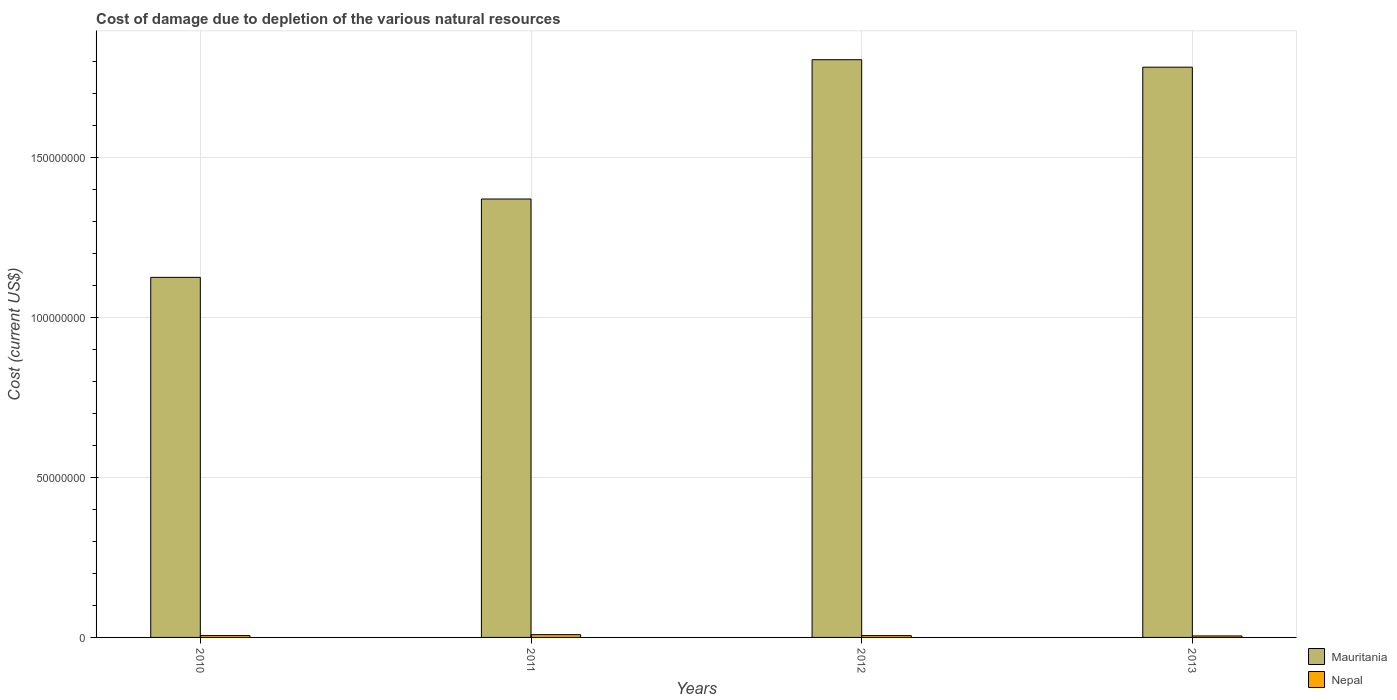Are the number of bars on each tick of the X-axis equal?
Keep it short and to the point. Yes. How many bars are there on the 2nd tick from the right?
Your response must be concise. 2. In how many cases, is the number of bars for a given year not equal to the number of legend labels?
Give a very brief answer. 0. What is the cost of damage caused due to the depletion of various natural resources in Nepal in 2011?
Your answer should be very brief. 8.69e+05. Across all years, what is the maximum cost of damage caused due to the depletion of various natural resources in Mauritania?
Make the answer very short. 1.81e+08. Across all years, what is the minimum cost of damage caused due to the depletion of various natural resources in Nepal?
Make the answer very short. 4.64e+05. What is the total cost of damage caused due to the depletion of various natural resources in Mauritania in the graph?
Offer a terse response. 6.09e+08. What is the difference between the cost of damage caused due to the depletion of various natural resources in Nepal in 2011 and that in 2012?
Keep it short and to the point. 2.92e+05. What is the difference between the cost of damage caused due to the depletion of various natural resources in Nepal in 2011 and the cost of damage caused due to the depletion of various natural resources in Mauritania in 2013?
Give a very brief answer. -1.77e+08. What is the average cost of damage caused due to the depletion of various natural resources in Mauritania per year?
Make the answer very short. 1.52e+08. In the year 2010, what is the difference between the cost of damage caused due to the depletion of various natural resources in Mauritania and cost of damage caused due to the depletion of various natural resources in Nepal?
Provide a short and direct response. 1.12e+08. In how many years, is the cost of damage caused due to the depletion of various natural resources in Mauritania greater than 150000000 US$?
Ensure brevity in your answer.  2. What is the ratio of the cost of damage caused due to the depletion of various natural resources in Nepal in 2010 to that in 2012?
Your response must be concise. 1.01. Is the cost of damage caused due to the depletion of various natural resources in Mauritania in 2011 less than that in 2013?
Your answer should be compact. Yes. What is the difference between the highest and the second highest cost of damage caused due to the depletion of various natural resources in Mauritania?
Provide a short and direct response. 2.34e+06. What is the difference between the highest and the lowest cost of damage caused due to the depletion of various natural resources in Nepal?
Your answer should be very brief. 4.05e+05. In how many years, is the cost of damage caused due to the depletion of various natural resources in Nepal greater than the average cost of damage caused due to the depletion of various natural resources in Nepal taken over all years?
Provide a short and direct response. 1. Is the sum of the cost of damage caused due to the depletion of various natural resources in Mauritania in 2011 and 2012 greater than the maximum cost of damage caused due to the depletion of various natural resources in Nepal across all years?
Offer a very short reply. Yes. What does the 1st bar from the left in 2012 represents?
Your answer should be very brief. Mauritania. What does the 2nd bar from the right in 2012 represents?
Your answer should be compact. Mauritania. How many bars are there?
Your answer should be compact. 8. Are all the bars in the graph horizontal?
Offer a terse response. No. How many years are there in the graph?
Give a very brief answer. 4. Are the values on the major ticks of Y-axis written in scientific E-notation?
Offer a very short reply. No. Does the graph contain any zero values?
Offer a terse response. No. Does the graph contain grids?
Keep it short and to the point. Yes. Where does the legend appear in the graph?
Ensure brevity in your answer.  Bottom right. How many legend labels are there?
Offer a very short reply. 2. What is the title of the graph?
Provide a short and direct response. Cost of damage due to depletion of the various natural resources. Does "Lebanon" appear as one of the legend labels in the graph?
Keep it short and to the point. No. What is the label or title of the Y-axis?
Make the answer very short. Cost (current US$). What is the Cost (current US$) in Mauritania in 2010?
Your response must be concise. 1.13e+08. What is the Cost (current US$) of Nepal in 2010?
Keep it short and to the point. 5.84e+05. What is the Cost (current US$) in Mauritania in 2011?
Your answer should be compact. 1.37e+08. What is the Cost (current US$) in Nepal in 2011?
Make the answer very short. 8.69e+05. What is the Cost (current US$) of Mauritania in 2012?
Give a very brief answer. 1.81e+08. What is the Cost (current US$) of Nepal in 2012?
Provide a succinct answer. 5.78e+05. What is the Cost (current US$) in Mauritania in 2013?
Keep it short and to the point. 1.78e+08. What is the Cost (current US$) of Nepal in 2013?
Your answer should be very brief. 4.64e+05. Across all years, what is the maximum Cost (current US$) in Mauritania?
Your answer should be very brief. 1.81e+08. Across all years, what is the maximum Cost (current US$) of Nepal?
Your response must be concise. 8.69e+05. Across all years, what is the minimum Cost (current US$) in Mauritania?
Offer a very short reply. 1.13e+08. Across all years, what is the minimum Cost (current US$) in Nepal?
Your answer should be very brief. 4.64e+05. What is the total Cost (current US$) in Mauritania in the graph?
Offer a very short reply. 6.09e+08. What is the total Cost (current US$) in Nepal in the graph?
Your answer should be very brief. 2.49e+06. What is the difference between the Cost (current US$) in Mauritania in 2010 and that in 2011?
Provide a succinct answer. -2.45e+07. What is the difference between the Cost (current US$) of Nepal in 2010 and that in 2011?
Your answer should be very brief. -2.85e+05. What is the difference between the Cost (current US$) of Mauritania in 2010 and that in 2012?
Give a very brief answer. -6.81e+07. What is the difference between the Cost (current US$) of Nepal in 2010 and that in 2012?
Offer a very short reply. 6660.31. What is the difference between the Cost (current US$) of Mauritania in 2010 and that in 2013?
Your answer should be very brief. -6.57e+07. What is the difference between the Cost (current US$) in Nepal in 2010 and that in 2013?
Make the answer very short. 1.20e+05. What is the difference between the Cost (current US$) of Mauritania in 2011 and that in 2012?
Make the answer very short. -4.36e+07. What is the difference between the Cost (current US$) of Nepal in 2011 and that in 2012?
Your response must be concise. 2.92e+05. What is the difference between the Cost (current US$) of Mauritania in 2011 and that in 2013?
Give a very brief answer. -4.12e+07. What is the difference between the Cost (current US$) of Nepal in 2011 and that in 2013?
Provide a short and direct response. 4.05e+05. What is the difference between the Cost (current US$) in Mauritania in 2012 and that in 2013?
Your response must be concise. 2.34e+06. What is the difference between the Cost (current US$) in Nepal in 2012 and that in 2013?
Give a very brief answer. 1.14e+05. What is the difference between the Cost (current US$) of Mauritania in 2010 and the Cost (current US$) of Nepal in 2011?
Your answer should be very brief. 1.12e+08. What is the difference between the Cost (current US$) of Mauritania in 2010 and the Cost (current US$) of Nepal in 2012?
Offer a very short reply. 1.12e+08. What is the difference between the Cost (current US$) in Mauritania in 2010 and the Cost (current US$) in Nepal in 2013?
Your response must be concise. 1.12e+08. What is the difference between the Cost (current US$) in Mauritania in 2011 and the Cost (current US$) in Nepal in 2012?
Offer a terse response. 1.37e+08. What is the difference between the Cost (current US$) of Mauritania in 2011 and the Cost (current US$) of Nepal in 2013?
Provide a short and direct response. 1.37e+08. What is the difference between the Cost (current US$) in Mauritania in 2012 and the Cost (current US$) in Nepal in 2013?
Your response must be concise. 1.80e+08. What is the average Cost (current US$) in Mauritania per year?
Ensure brevity in your answer.  1.52e+08. What is the average Cost (current US$) in Nepal per year?
Provide a short and direct response. 6.24e+05. In the year 2010, what is the difference between the Cost (current US$) of Mauritania and Cost (current US$) of Nepal?
Offer a very short reply. 1.12e+08. In the year 2011, what is the difference between the Cost (current US$) of Mauritania and Cost (current US$) of Nepal?
Make the answer very short. 1.36e+08. In the year 2012, what is the difference between the Cost (current US$) of Mauritania and Cost (current US$) of Nepal?
Offer a very short reply. 1.80e+08. In the year 2013, what is the difference between the Cost (current US$) in Mauritania and Cost (current US$) in Nepal?
Ensure brevity in your answer.  1.78e+08. What is the ratio of the Cost (current US$) in Mauritania in 2010 to that in 2011?
Keep it short and to the point. 0.82. What is the ratio of the Cost (current US$) in Nepal in 2010 to that in 2011?
Offer a very short reply. 0.67. What is the ratio of the Cost (current US$) of Mauritania in 2010 to that in 2012?
Your answer should be compact. 0.62. What is the ratio of the Cost (current US$) in Nepal in 2010 to that in 2012?
Provide a short and direct response. 1.01. What is the ratio of the Cost (current US$) of Mauritania in 2010 to that in 2013?
Provide a short and direct response. 0.63. What is the ratio of the Cost (current US$) in Nepal in 2010 to that in 2013?
Ensure brevity in your answer.  1.26. What is the ratio of the Cost (current US$) of Mauritania in 2011 to that in 2012?
Your answer should be compact. 0.76. What is the ratio of the Cost (current US$) in Nepal in 2011 to that in 2012?
Keep it short and to the point. 1.51. What is the ratio of the Cost (current US$) in Mauritania in 2011 to that in 2013?
Provide a short and direct response. 0.77. What is the ratio of the Cost (current US$) of Nepal in 2011 to that in 2013?
Your answer should be compact. 1.87. What is the ratio of the Cost (current US$) in Mauritania in 2012 to that in 2013?
Make the answer very short. 1.01. What is the ratio of the Cost (current US$) in Nepal in 2012 to that in 2013?
Offer a terse response. 1.25. What is the difference between the highest and the second highest Cost (current US$) of Mauritania?
Offer a very short reply. 2.34e+06. What is the difference between the highest and the second highest Cost (current US$) of Nepal?
Give a very brief answer. 2.85e+05. What is the difference between the highest and the lowest Cost (current US$) of Mauritania?
Provide a succinct answer. 6.81e+07. What is the difference between the highest and the lowest Cost (current US$) of Nepal?
Offer a terse response. 4.05e+05. 